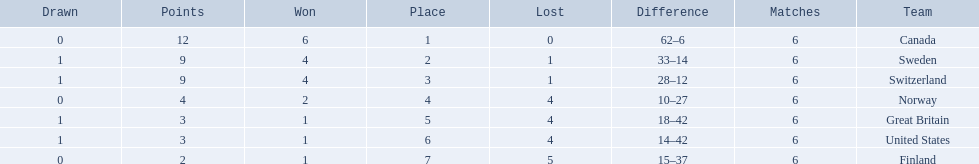Which are the two countries? Switzerland, Great Britain. What were the point totals for each of these countries? 9, 3. Of these point totals, which is better? 9. Which country earned this point total? Switzerland. 